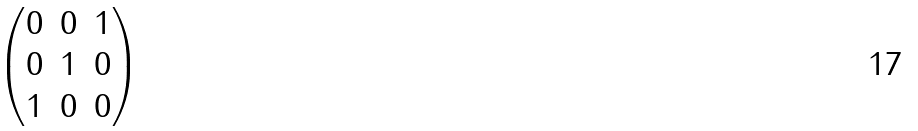<formula> <loc_0><loc_0><loc_500><loc_500>\begin{pmatrix} 0 & 0 & 1 \\ 0 & 1 & 0 \\ 1 & 0 & 0 \end{pmatrix}</formula> 